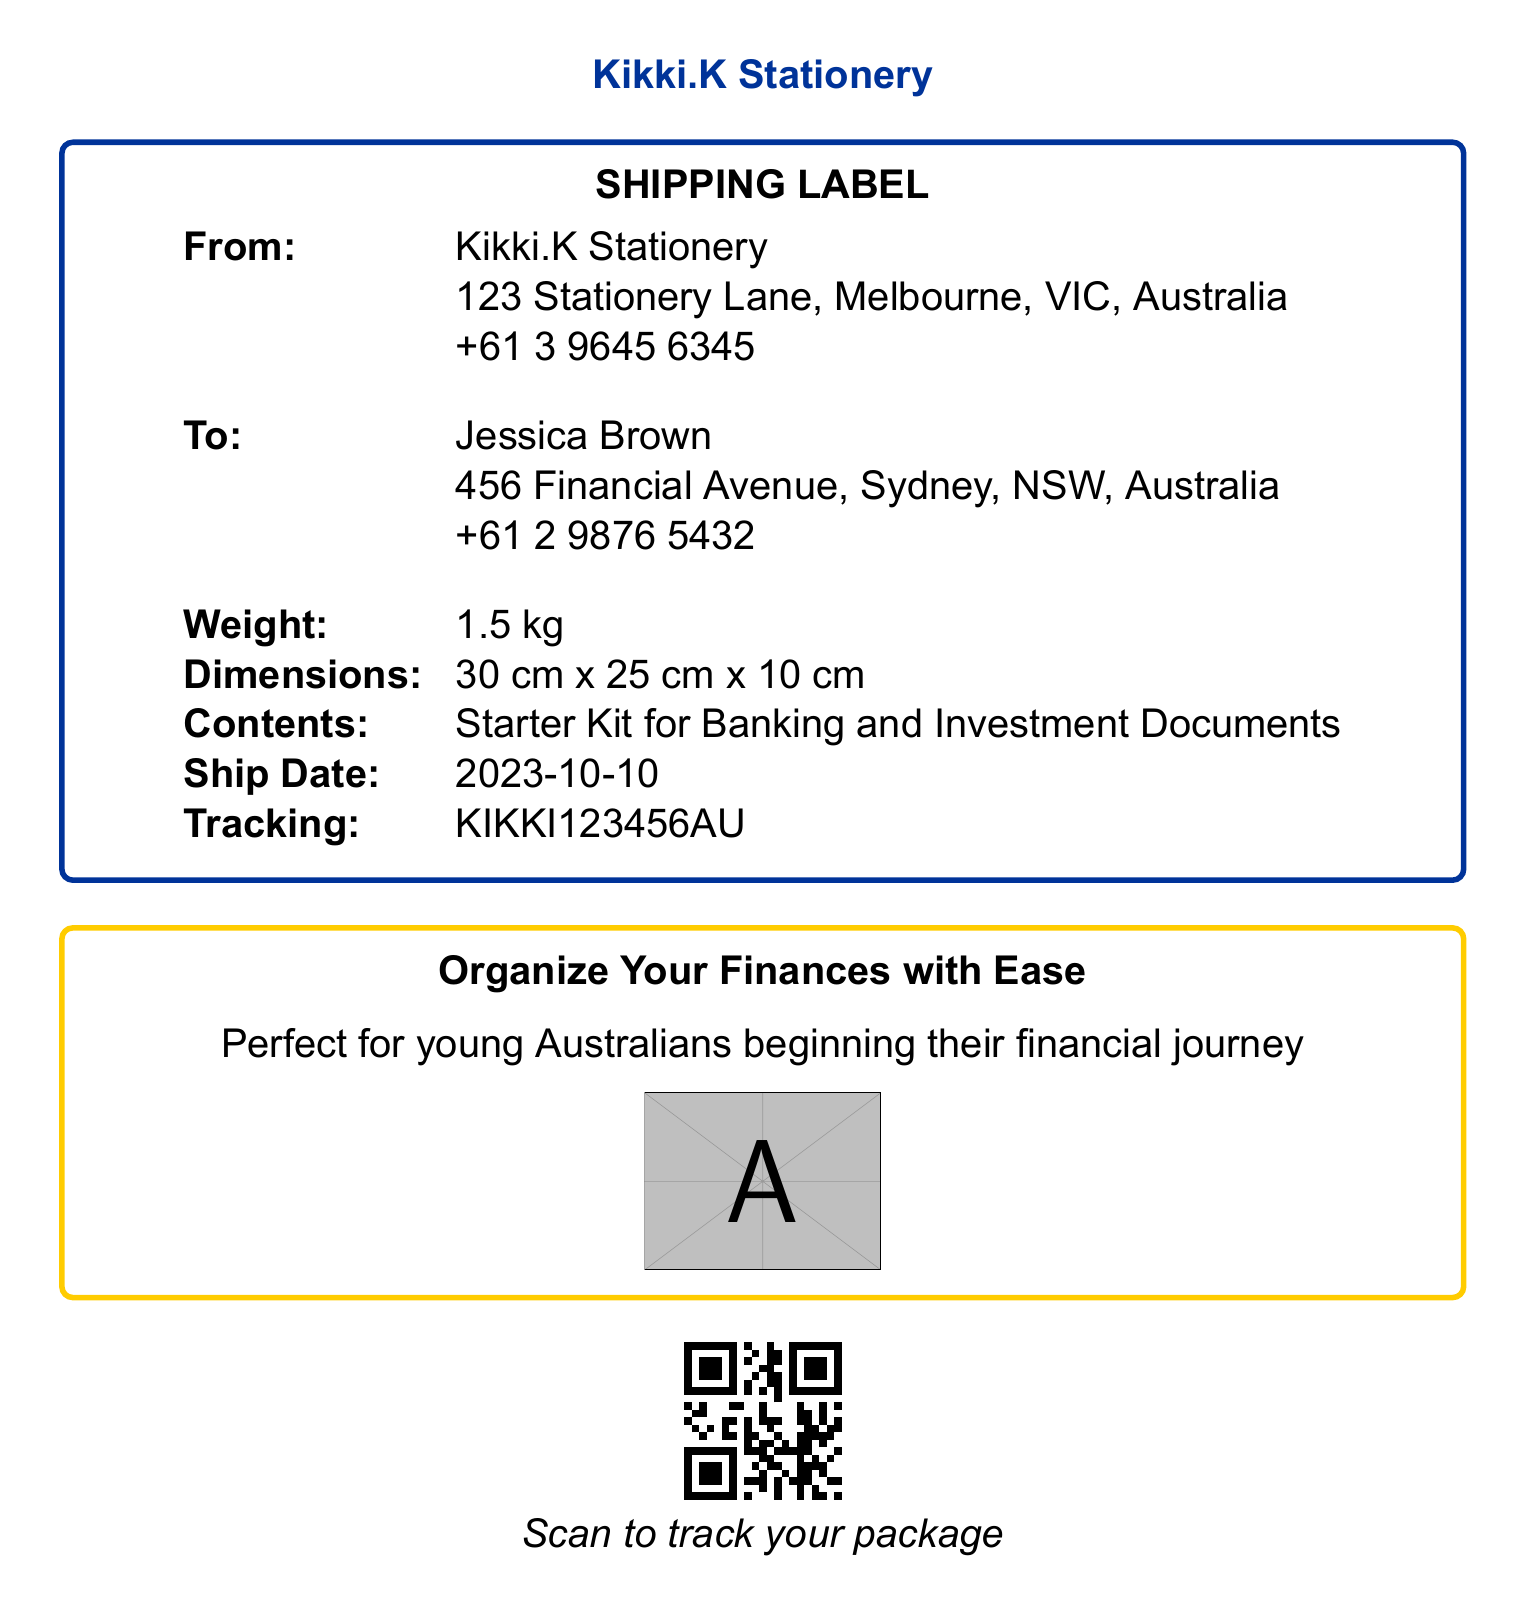What is the name of the sender? The sender's name is listed as Kikki.K Stationery at the top of the shipping label.
Answer: Kikki.K Stationery What is the tracking number? The tracking number is printed towards the bottom of the shipping label.
Answer: KIKKI123456AU What is the weight of the package? The weight is specified under the 'Weight' section of the shipping label.
Answer: 1.5 kg What is the ship date? The shipping date is provided in the 'Ship Date' section of the label.
Answer: 2023-10-10 What are the dimensions of the package? The dimensions are stated next to the 'Dimensions' label on the shipping label.
Answer: 30 cm x 25 cm x 10 cm Who is the recipient? The recipient's name is listed below the 'To:' section on the shipping label.
Answer: Jessica Brown What is included in the package? The contents of the package are mentioned in the 'Contents' section of the label.
Answer: Starter Kit for Banking and Investment Documents What color is the sender's box? The sender's box is outlined in a specific color as indicated in the document.
Answer: Australian blue What is the purpose of the shipping label? The purpose is indicated in the section that mentions organizing financial documents.
Answer: Organize Your Finances with Ease 